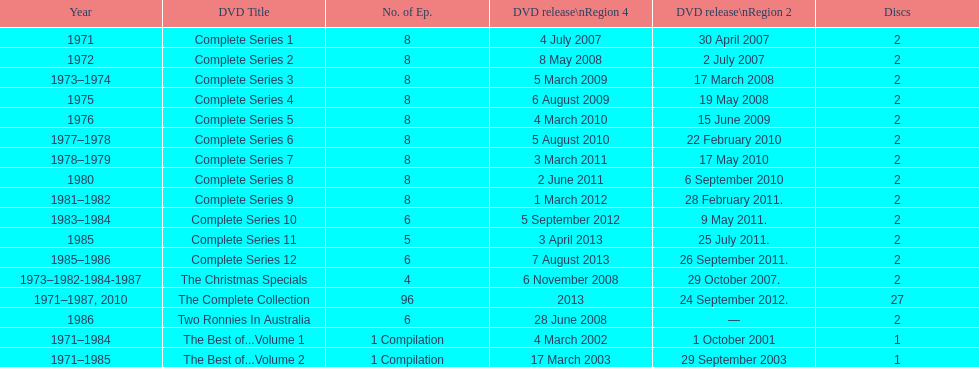How many series had 8 episodes? 9. 